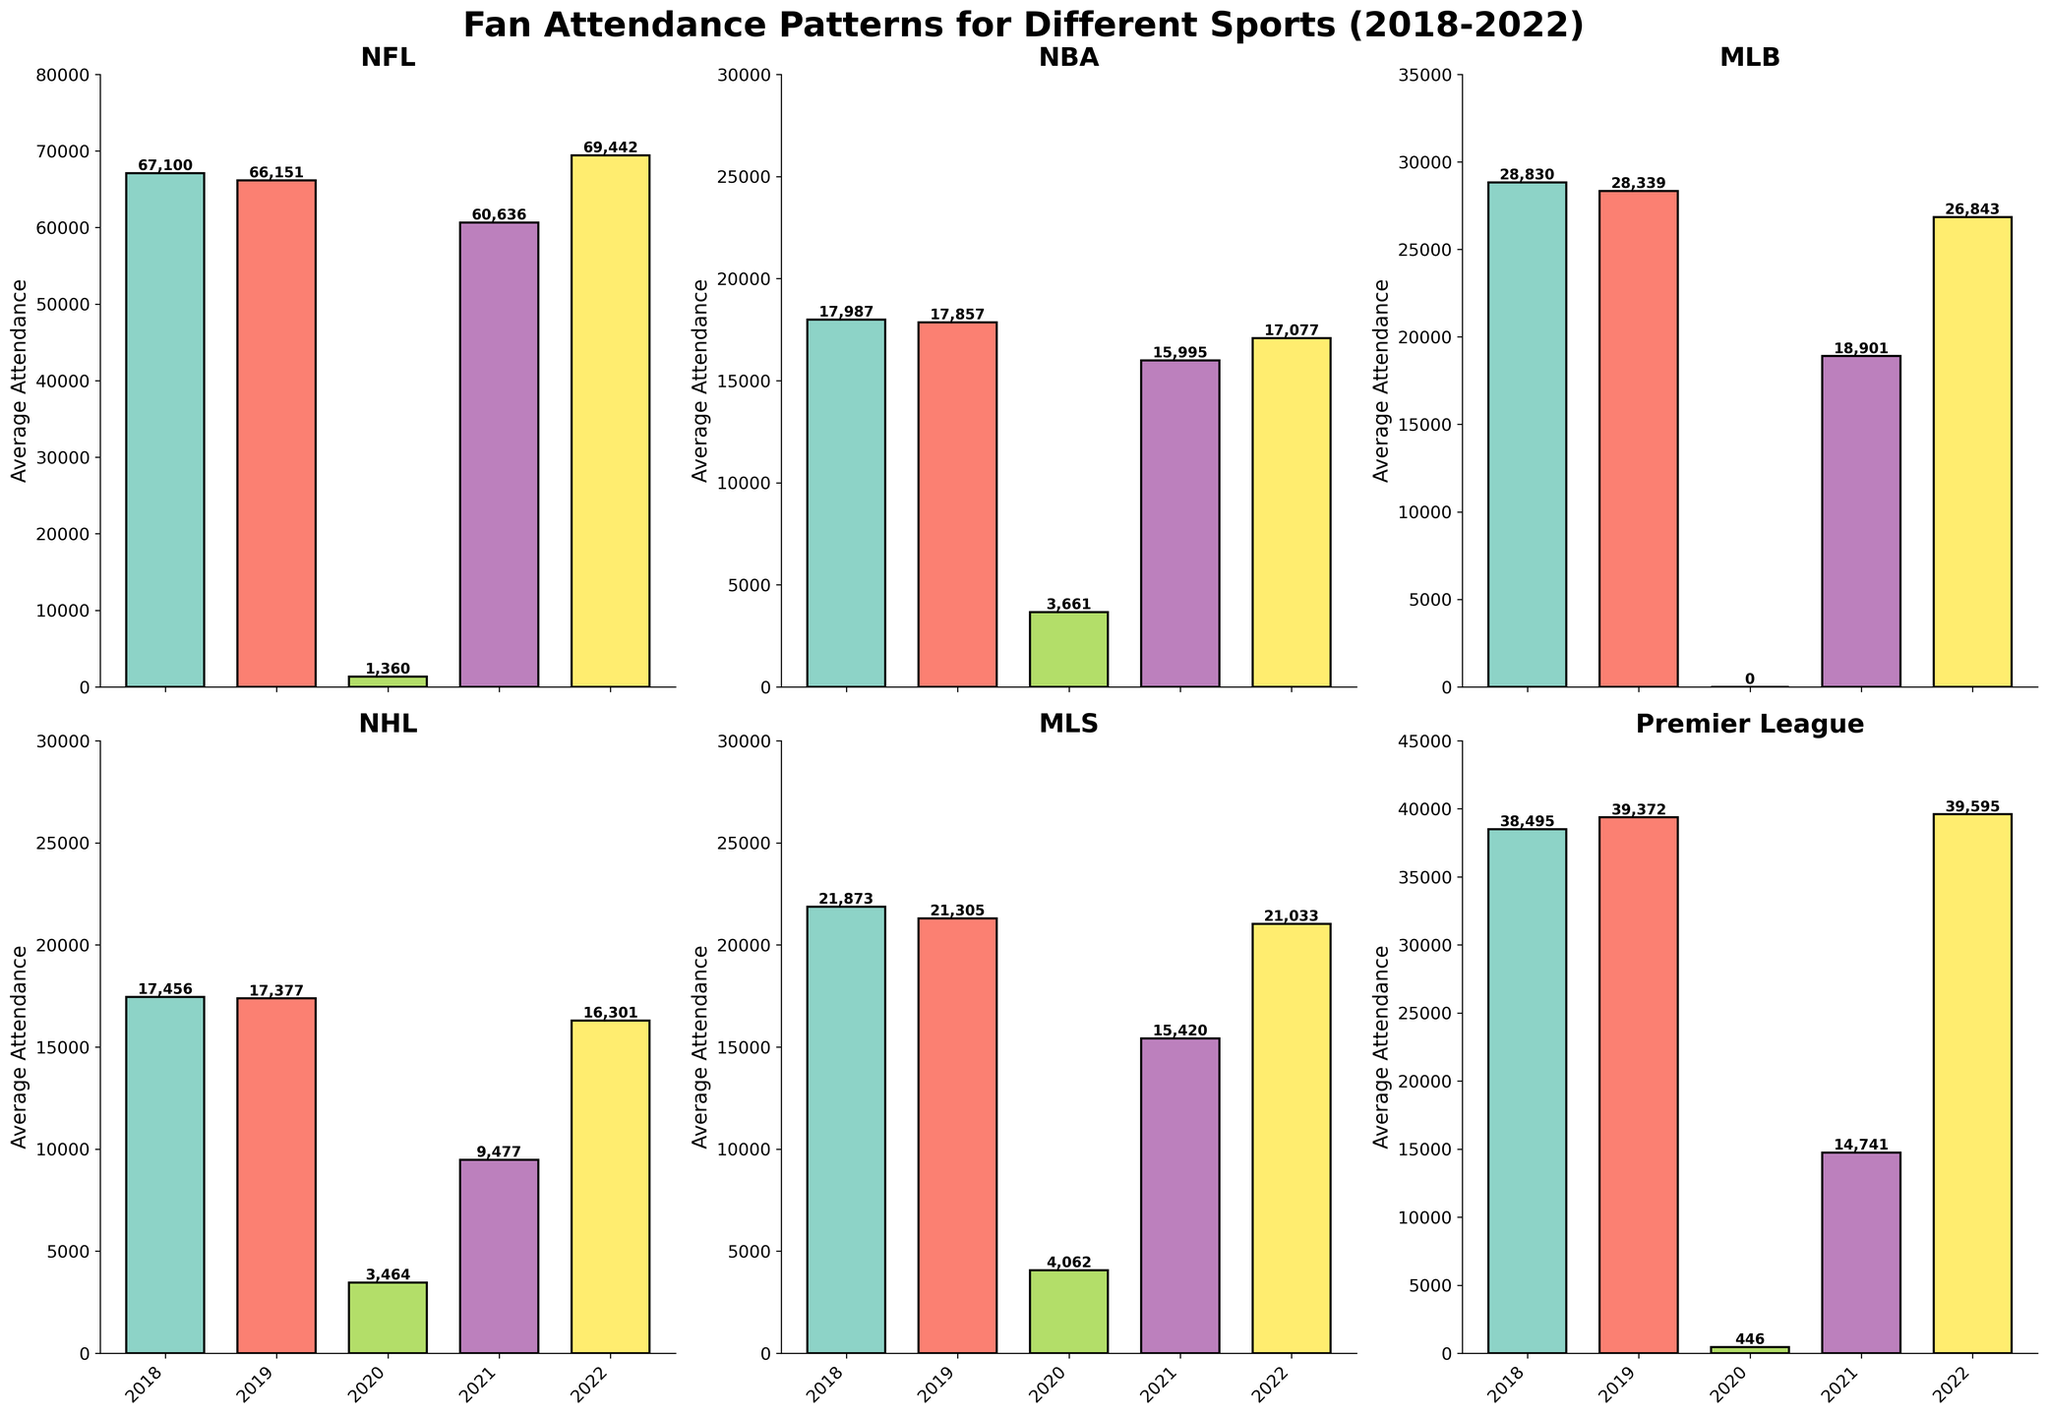What is the overall trend in NFL fan attendance from 2018 to 2022? The NFL attendance trend from 2018 to 2022 shows a decline from 2018 (67,100) to 2019 (66,151), a significant drop in 2020 (1,360), a recovery in 2021 (60,636), and a further increase in 2022 (69,442). This indicates a dip due to the pandemic in 2020, followed by a recovery.
Answer: Decline, followed by a recovery In which year did the NBA experience its lowest average attendance, and what might be the reason? The NBA experienced its lowest average attendance in 2020 with 3,661 attendees. This significant drop is likely due to the COVID-19 pandemic, which forced games to be played without fans or with restricted attendance.
Answer: 2020 Compare the MLB average attendance in 2018 and 2021. What is the difference, and what factors could have contributed to this change? The MLB average attendance was 28,830 in 2018 and 18,901 in 2021. The difference is 28,830 - 18,901 = 9,929 fewer attendees in 2021. Factors likely contributing to this decreased attendance include the pandemic's impact and varying local health guidelines.
Answer: 9,929 fewer attendees in 2021 Which sport had the most significant drop in attendance from 2019 to 2020, and by how much did it drop? The Premier League had the most significant drop in attendance from 2019 (39,372) to 2020 (446). The drop is 39,372 - 446 = 38,926 attendees. This extreme reduction is attributed to the COVID-19 pandemic.
Answer: Premier League, 38,926 attendees What is the average attendance for the Premier League across all the seasons shown in the figure? To find the average attendance: sum up all values (2018: 38,495, 2019: 39,372, 2020: 446, 2021: 14,741, 2022: 39,595) and divide by the number of years (5). The calculation is (38,495 + 39,372 + 446 + 14,741 + 39,595) / 5 = 26,929.8.
Answer: 26,929.8 Which sport had the highest average attendance in 2022 and what is the value? By comparing all sports' attendance in 2022, the NFL had the highest average attendance with 69,442 attendees.
Answer: NFL, 69,442 attendees How did the average attendance for MLS change from 2020 to 2022? The MLS average attendance increased from 2020 (4,062) to 2021 (15,420), and again to 2022 (21,033). This indicates a recovery path post-pandemic.
Answer: Increased Of the sports listed, which experienced the least variation in attendance from 2018 to 2022? The NBA had relatively less variation compared to others: 17,987 (2018), 17,857 (2019), 3,661 (2020), 15,995 (2021), and 17,077 (2022). It shows a notable drop in 2020 but maintains a consistent range otherwise.
Answer: NBA What visual cue in the figure indicates the significant impact of the pandemic in 2020 on fan attendance across all sports? The much shorter bars in the year 2020 across all subplots visually indicate the significant drop in fan attendance due to the pandemic.
Answer: Shorter bars in 2020 